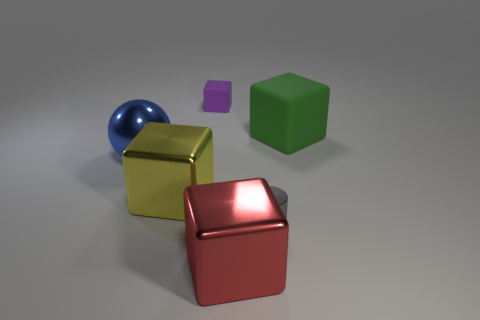There is a rubber thing that is to the right of the small gray shiny cylinder; are there any gray cylinders that are right of it? Upon examination of the image, no additional gray cylinders are visible to the right of the small gray cylinder. The objects present include a red cube positioned in front and a green cube and a blue sphere to the left—no objects are placed to its right. 